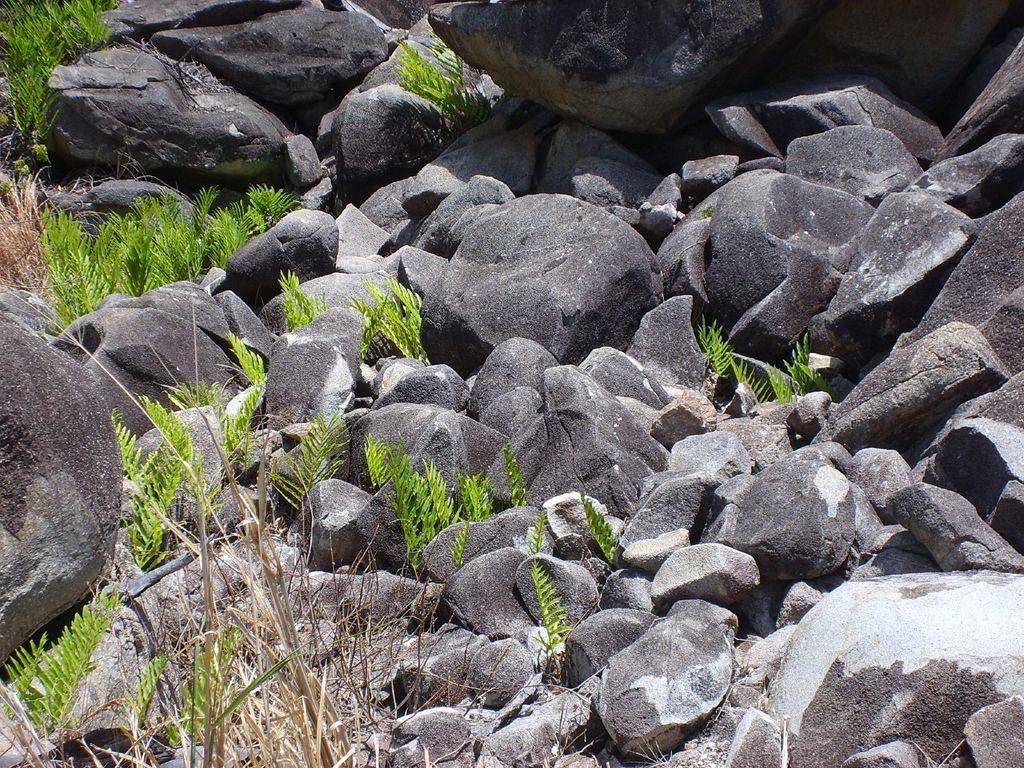How would you summarize this image in a sentence or two? This image is taken outdoors. In this image there are many rocks and stones on the ground and there are a few plants with green leaves. 